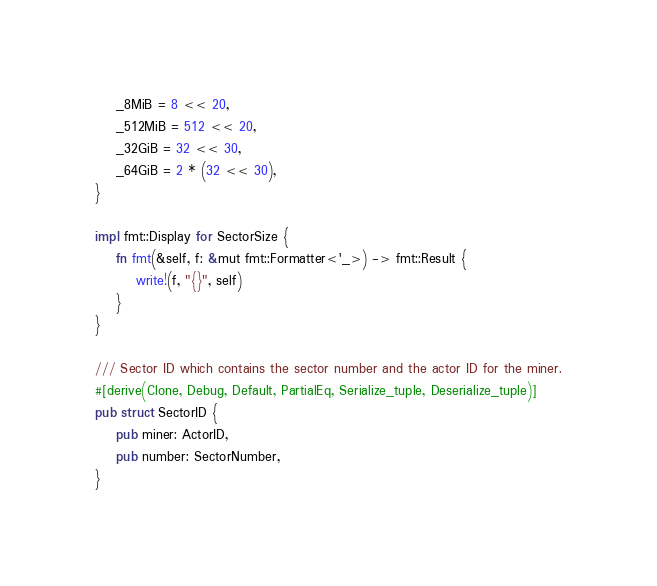<code> <loc_0><loc_0><loc_500><loc_500><_Rust_>    _8MiB = 8 << 20,
    _512MiB = 512 << 20,
    _32GiB = 32 << 30,
    _64GiB = 2 * (32 << 30),
}

impl fmt::Display for SectorSize {
    fn fmt(&self, f: &mut fmt::Formatter<'_>) -> fmt::Result {
        write!(f, "{}", self)
    }
}

/// Sector ID which contains the sector number and the actor ID for the miner.
#[derive(Clone, Debug, Default, PartialEq, Serialize_tuple, Deserialize_tuple)]
pub struct SectorID {
    pub miner: ActorID,
    pub number: SectorNumber,
}
</code> 